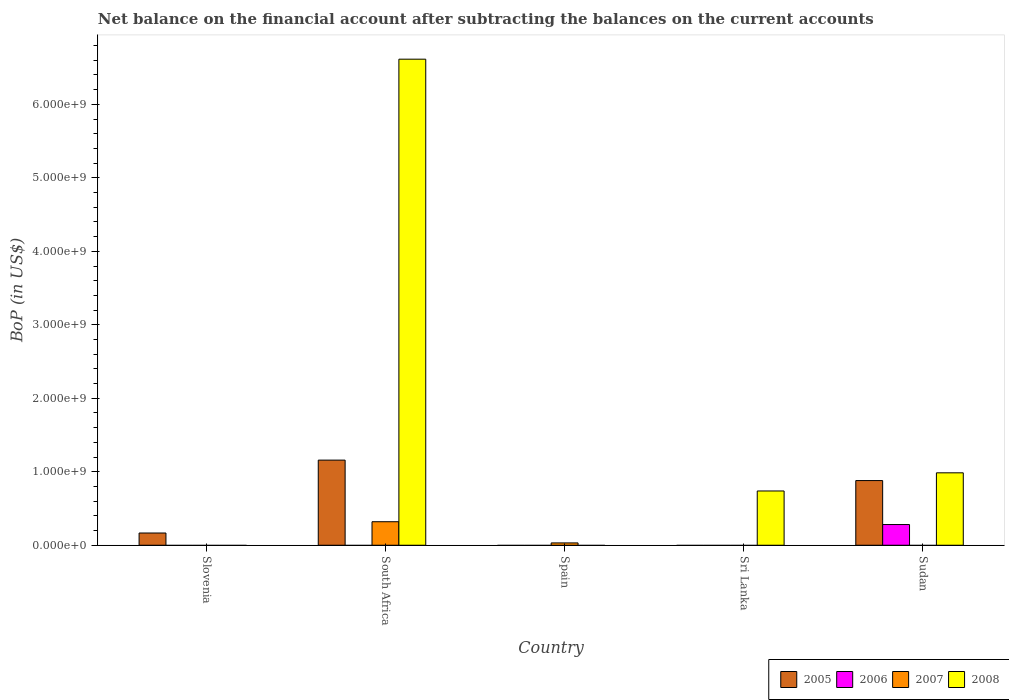Are the number of bars per tick equal to the number of legend labels?
Offer a very short reply. No. How many bars are there on the 1st tick from the right?
Keep it short and to the point. 3. What is the label of the 2nd group of bars from the left?
Offer a very short reply. South Africa. In how many cases, is the number of bars for a given country not equal to the number of legend labels?
Your response must be concise. 5. What is the Balance of Payments in 2006 in South Africa?
Give a very brief answer. 0. Across all countries, what is the maximum Balance of Payments in 2005?
Make the answer very short. 1.16e+09. Across all countries, what is the minimum Balance of Payments in 2007?
Offer a terse response. 0. In which country was the Balance of Payments in 2008 maximum?
Your answer should be compact. South Africa. What is the total Balance of Payments in 2005 in the graph?
Provide a short and direct response. 2.21e+09. What is the difference between the Balance of Payments in 2005 in Slovenia and that in Sudan?
Your answer should be very brief. -7.14e+08. What is the difference between the Balance of Payments in 2005 in Spain and the Balance of Payments in 2006 in Sudan?
Ensure brevity in your answer.  -2.82e+08. What is the average Balance of Payments in 2005 per country?
Your answer should be very brief. 4.41e+08. What is the difference between the Balance of Payments of/in 2007 and Balance of Payments of/in 2008 in South Africa?
Provide a succinct answer. -6.30e+09. In how many countries, is the Balance of Payments in 2006 greater than 6600000000 US$?
Keep it short and to the point. 0. What is the difference between the highest and the second highest Balance of Payments in 2008?
Ensure brevity in your answer.  -2.47e+08. What is the difference between the highest and the lowest Balance of Payments in 2008?
Your answer should be compact. 6.62e+09. Is the sum of the Balance of Payments in 2005 in Slovenia and South Africa greater than the maximum Balance of Payments in 2007 across all countries?
Your answer should be compact. Yes. Is it the case that in every country, the sum of the Balance of Payments in 2006 and Balance of Payments in 2005 is greater than the sum of Balance of Payments in 2007 and Balance of Payments in 2008?
Offer a terse response. No. Is it the case that in every country, the sum of the Balance of Payments in 2007 and Balance of Payments in 2005 is greater than the Balance of Payments in 2008?
Offer a very short reply. No. Are all the bars in the graph horizontal?
Ensure brevity in your answer.  No. What is the difference between two consecutive major ticks on the Y-axis?
Your answer should be very brief. 1.00e+09. Where does the legend appear in the graph?
Ensure brevity in your answer.  Bottom right. What is the title of the graph?
Offer a terse response. Net balance on the financial account after subtracting the balances on the current accounts. Does "1984" appear as one of the legend labels in the graph?
Your response must be concise. No. What is the label or title of the X-axis?
Ensure brevity in your answer.  Country. What is the label or title of the Y-axis?
Make the answer very short. BoP (in US$). What is the BoP (in US$) of 2005 in Slovenia?
Your answer should be very brief. 1.66e+08. What is the BoP (in US$) in 2006 in Slovenia?
Provide a succinct answer. 0. What is the BoP (in US$) of 2008 in Slovenia?
Offer a very short reply. 0. What is the BoP (in US$) of 2005 in South Africa?
Provide a succinct answer. 1.16e+09. What is the BoP (in US$) of 2007 in South Africa?
Provide a short and direct response. 3.20e+08. What is the BoP (in US$) in 2008 in South Africa?
Your answer should be compact. 6.62e+09. What is the BoP (in US$) of 2005 in Spain?
Keep it short and to the point. 0. What is the BoP (in US$) of 2007 in Spain?
Your response must be concise. 3.16e+07. What is the BoP (in US$) of 2007 in Sri Lanka?
Keep it short and to the point. 0. What is the BoP (in US$) in 2008 in Sri Lanka?
Offer a very short reply. 7.39e+08. What is the BoP (in US$) in 2005 in Sudan?
Keep it short and to the point. 8.80e+08. What is the BoP (in US$) of 2006 in Sudan?
Offer a very short reply. 2.82e+08. What is the BoP (in US$) in 2007 in Sudan?
Give a very brief answer. 0. What is the BoP (in US$) of 2008 in Sudan?
Your answer should be compact. 9.86e+08. Across all countries, what is the maximum BoP (in US$) of 2005?
Your answer should be very brief. 1.16e+09. Across all countries, what is the maximum BoP (in US$) of 2006?
Your answer should be very brief. 2.82e+08. Across all countries, what is the maximum BoP (in US$) in 2007?
Your answer should be compact. 3.20e+08. Across all countries, what is the maximum BoP (in US$) of 2008?
Provide a succinct answer. 6.62e+09. Across all countries, what is the minimum BoP (in US$) in 2005?
Keep it short and to the point. 0. Across all countries, what is the minimum BoP (in US$) of 2008?
Offer a very short reply. 0. What is the total BoP (in US$) in 2005 in the graph?
Give a very brief answer. 2.21e+09. What is the total BoP (in US$) of 2006 in the graph?
Ensure brevity in your answer.  2.82e+08. What is the total BoP (in US$) of 2007 in the graph?
Offer a very short reply. 3.52e+08. What is the total BoP (in US$) in 2008 in the graph?
Ensure brevity in your answer.  8.34e+09. What is the difference between the BoP (in US$) of 2005 in Slovenia and that in South Africa?
Provide a succinct answer. -9.92e+08. What is the difference between the BoP (in US$) of 2005 in Slovenia and that in Sudan?
Your answer should be compact. -7.14e+08. What is the difference between the BoP (in US$) of 2007 in South Africa and that in Spain?
Your answer should be very brief. 2.88e+08. What is the difference between the BoP (in US$) in 2008 in South Africa and that in Sri Lanka?
Offer a very short reply. 5.88e+09. What is the difference between the BoP (in US$) in 2005 in South Africa and that in Sudan?
Your response must be concise. 2.78e+08. What is the difference between the BoP (in US$) of 2008 in South Africa and that in Sudan?
Ensure brevity in your answer.  5.63e+09. What is the difference between the BoP (in US$) of 2008 in Sri Lanka and that in Sudan?
Offer a very short reply. -2.47e+08. What is the difference between the BoP (in US$) of 2005 in Slovenia and the BoP (in US$) of 2007 in South Africa?
Keep it short and to the point. -1.54e+08. What is the difference between the BoP (in US$) of 2005 in Slovenia and the BoP (in US$) of 2008 in South Africa?
Offer a very short reply. -6.45e+09. What is the difference between the BoP (in US$) in 2005 in Slovenia and the BoP (in US$) in 2007 in Spain?
Offer a very short reply. 1.35e+08. What is the difference between the BoP (in US$) of 2005 in Slovenia and the BoP (in US$) of 2008 in Sri Lanka?
Your answer should be compact. -5.72e+08. What is the difference between the BoP (in US$) in 2005 in Slovenia and the BoP (in US$) in 2006 in Sudan?
Make the answer very short. -1.15e+08. What is the difference between the BoP (in US$) in 2005 in Slovenia and the BoP (in US$) in 2008 in Sudan?
Provide a short and direct response. -8.19e+08. What is the difference between the BoP (in US$) of 2005 in South Africa and the BoP (in US$) of 2007 in Spain?
Offer a terse response. 1.13e+09. What is the difference between the BoP (in US$) in 2005 in South Africa and the BoP (in US$) in 2008 in Sri Lanka?
Your answer should be very brief. 4.20e+08. What is the difference between the BoP (in US$) of 2007 in South Africa and the BoP (in US$) of 2008 in Sri Lanka?
Provide a succinct answer. -4.19e+08. What is the difference between the BoP (in US$) of 2005 in South Africa and the BoP (in US$) of 2006 in Sudan?
Provide a short and direct response. 8.77e+08. What is the difference between the BoP (in US$) in 2005 in South Africa and the BoP (in US$) in 2008 in Sudan?
Offer a terse response. 1.73e+08. What is the difference between the BoP (in US$) in 2007 in South Africa and the BoP (in US$) in 2008 in Sudan?
Offer a terse response. -6.66e+08. What is the difference between the BoP (in US$) in 2007 in Spain and the BoP (in US$) in 2008 in Sri Lanka?
Ensure brevity in your answer.  -7.07e+08. What is the difference between the BoP (in US$) in 2007 in Spain and the BoP (in US$) in 2008 in Sudan?
Your response must be concise. -9.54e+08. What is the average BoP (in US$) in 2005 per country?
Keep it short and to the point. 4.41e+08. What is the average BoP (in US$) of 2006 per country?
Your answer should be compact. 5.63e+07. What is the average BoP (in US$) of 2007 per country?
Your answer should be compact. 7.03e+07. What is the average BoP (in US$) of 2008 per country?
Make the answer very short. 1.67e+09. What is the difference between the BoP (in US$) of 2005 and BoP (in US$) of 2007 in South Africa?
Ensure brevity in your answer.  8.39e+08. What is the difference between the BoP (in US$) in 2005 and BoP (in US$) in 2008 in South Africa?
Make the answer very short. -5.46e+09. What is the difference between the BoP (in US$) of 2007 and BoP (in US$) of 2008 in South Africa?
Your answer should be very brief. -6.30e+09. What is the difference between the BoP (in US$) of 2005 and BoP (in US$) of 2006 in Sudan?
Provide a short and direct response. 5.98e+08. What is the difference between the BoP (in US$) in 2005 and BoP (in US$) in 2008 in Sudan?
Offer a terse response. -1.05e+08. What is the difference between the BoP (in US$) in 2006 and BoP (in US$) in 2008 in Sudan?
Offer a terse response. -7.04e+08. What is the ratio of the BoP (in US$) in 2005 in Slovenia to that in South Africa?
Provide a short and direct response. 0.14. What is the ratio of the BoP (in US$) of 2005 in Slovenia to that in Sudan?
Keep it short and to the point. 0.19. What is the ratio of the BoP (in US$) of 2007 in South Africa to that in Spain?
Provide a short and direct response. 10.11. What is the ratio of the BoP (in US$) in 2008 in South Africa to that in Sri Lanka?
Offer a very short reply. 8.96. What is the ratio of the BoP (in US$) in 2005 in South Africa to that in Sudan?
Provide a short and direct response. 1.32. What is the ratio of the BoP (in US$) in 2008 in South Africa to that in Sudan?
Ensure brevity in your answer.  6.71. What is the ratio of the BoP (in US$) of 2008 in Sri Lanka to that in Sudan?
Your response must be concise. 0.75. What is the difference between the highest and the second highest BoP (in US$) in 2005?
Your answer should be very brief. 2.78e+08. What is the difference between the highest and the second highest BoP (in US$) in 2008?
Give a very brief answer. 5.63e+09. What is the difference between the highest and the lowest BoP (in US$) of 2005?
Give a very brief answer. 1.16e+09. What is the difference between the highest and the lowest BoP (in US$) of 2006?
Ensure brevity in your answer.  2.82e+08. What is the difference between the highest and the lowest BoP (in US$) in 2007?
Ensure brevity in your answer.  3.20e+08. What is the difference between the highest and the lowest BoP (in US$) in 2008?
Give a very brief answer. 6.62e+09. 